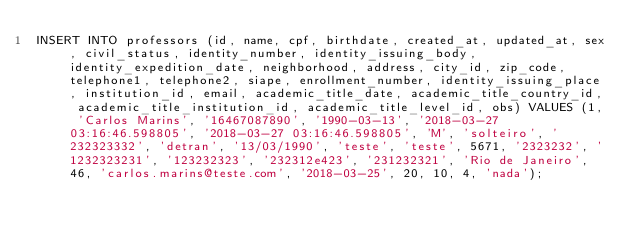Convert code to text. <code><loc_0><loc_0><loc_500><loc_500><_SQL_>INSERT INTO professors (id, name, cpf, birthdate, created_at, updated_at, sex, civil_status, identity_number, identity_issuing_body, identity_expedition_date, neighborhood, address, city_id, zip_code, telephone1, telephone2, siape, enrollment_number, identity_issuing_place, institution_id, email, academic_title_date, academic_title_country_id, academic_title_institution_id, academic_title_level_id, obs) VALUES (1, 'Carlos Marins', '16467087890', '1990-03-13', '2018-03-27 03:16:46.598805', '2018-03-27 03:16:46.598805', 'M', 'solteiro', '232323332', 'detran', '13/03/1990', 'teste', 'teste', 5671, '2323232', '1232323231', '123232323', '232312e423', '231232321', 'Rio de Janeiro', 46, 'carlos.marins@teste.com', '2018-03-25', 20, 10, 4, 'nada');</code> 